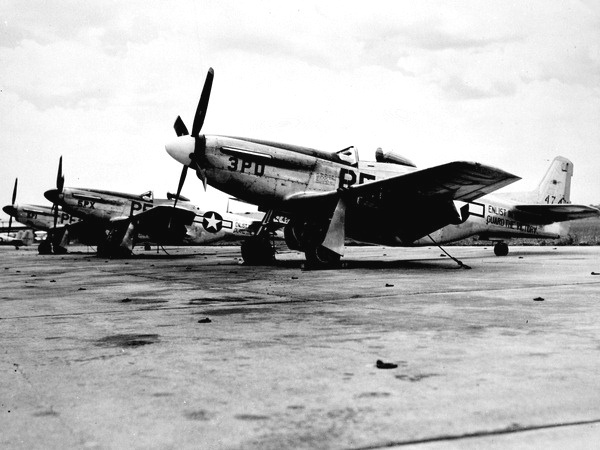Describe the objects in this image and their specific colors. I can see airplane in white, black, lightgray, gray, and darkgray tones, airplane in white, black, darkgray, lightgray, and gray tones, and airplane in white, black, darkgray, gray, and lightgray tones in this image. 